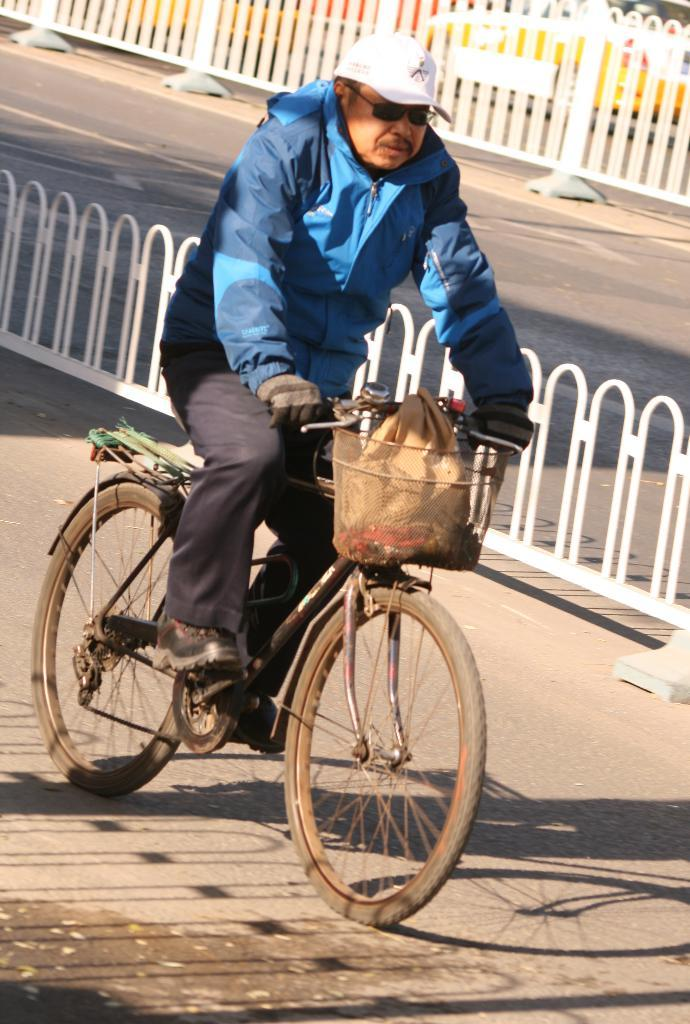What is the main subject of the picture? The main subject of the picture is a guy. What is the guy wearing on his upper body? The guy is wearing a blue jacket. What accessory is the guy wearing on his face? The guy is wearing spectacles. What headgear is the guy wearing? The guy is wearing a hat. What mode of transportation is the guy using? The guy is riding a bicycle. What can be seen in the street behind the guy? There are white color grills in the street behind the guy. What type of power does the guy generate while riding the bicycle in the image? The image does not show the guy generating any power; he is simply riding a bicycle. Can you see a swing in the image? No, there is no swing present in the image. 